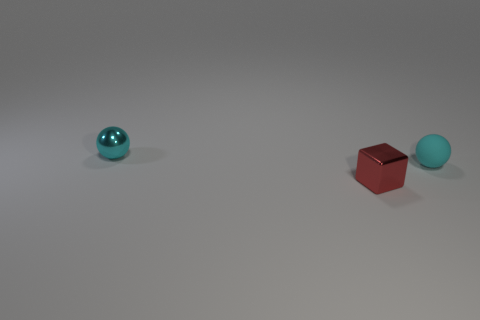There is a small matte sphere; does it have the same color as the tiny metal thing that is behind the red object?
Your response must be concise. Yes. Is there any other thing that is the same shape as the tiny red metallic object?
Offer a very short reply. No. What number of shiny objects are either cyan things or blue cylinders?
Your answer should be compact. 1. What number of small things have the same color as the small matte sphere?
Offer a terse response. 1. What material is the tiny red object in front of the tiny metallic object behind the tiny cyan matte sphere?
Give a very brief answer. Metal. What number of other red cubes are the same size as the metal cube?
Ensure brevity in your answer.  0. What number of tiny shiny objects are the same shape as the matte object?
Keep it short and to the point. 1. Are there the same number of small objects left of the tiny cyan rubber object and large matte cubes?
Keep it short and to the point. No. There is a red object that is the same size as the cyan metal object; what shape is it?
Provide a succinct answer. Cube. Are there any big gray rubber things that have the same shape as the tiny cyan metal thing?
Make the answer very short. No. 